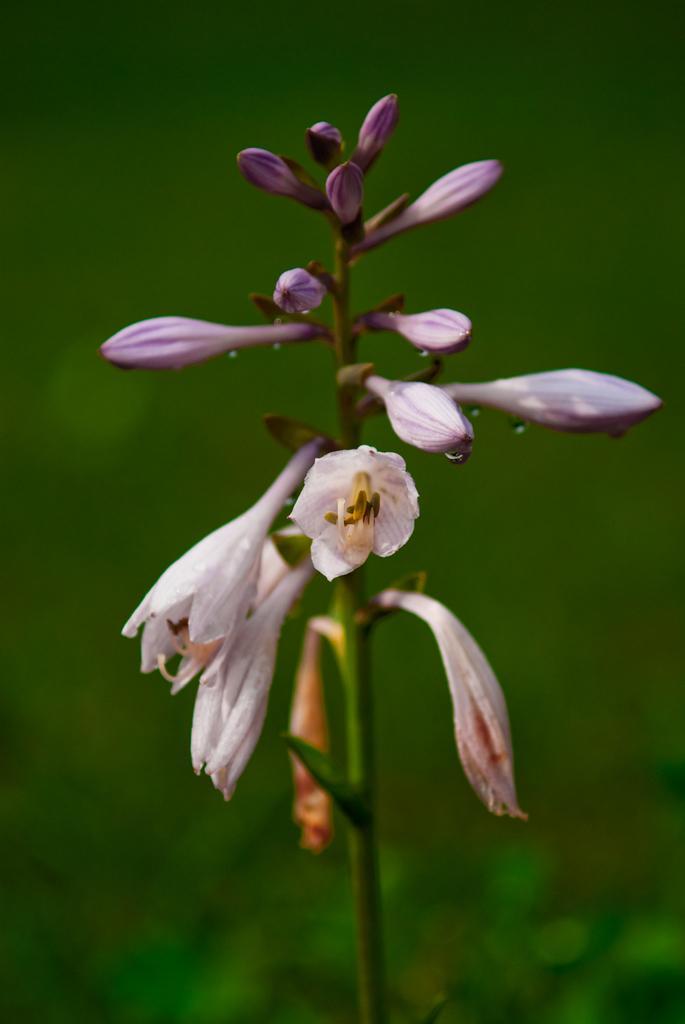Describe this image in one or two sentences. In this image we can see flowers and buds to the stem. 